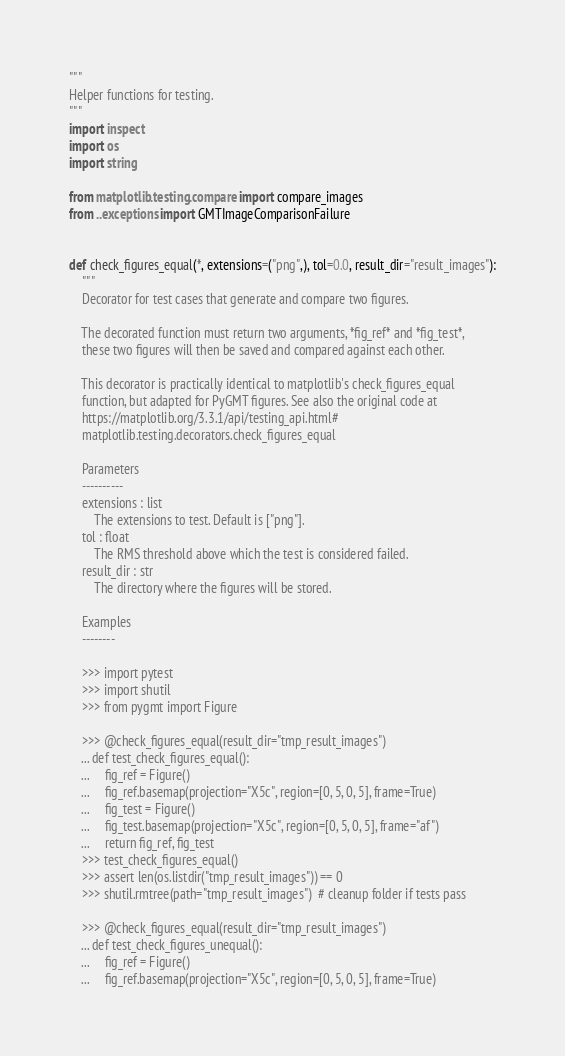<code> <loc_0><loc_0><loc_500><loc_500><_Python_>"""
Helper functions for testing.
"""
import inspect
import os
import string

from matplotlib.testing.compare import compare_images
from ..exceptions import GMTImageComparisonFailure


def check_figures_equal(*, extensions=("png",), tol=0.0, result_dir="result_images"):
    """
    Decorator for test cases that generate and compare two figures.

    The decorated function must return two arguments, *fig_ref* and *fig_test*,
    these two figures will then be saved and compared against each other.

    This decorator is practically identical to matplotlib's check_figures_equal
    function, but adapted for PyGMT figures. See also the original code at
    https://matplotlib.org/3.3.1/api/testing_api.html#
    matplotlib.testing.decorators.check_figures_equal

    Parameters
    ----------
    extensions : list
        The extensions to test. Default is ["png"].
    tol : float
        The RMS threshold above which the test is considered failed.
    result_dir : str
        The directory where the figures will be stored.

    Examples
    --------

    >>> import pytest
    >>> import shutil
    >>> from pygmt import Figure

    >>> @check_figures_equal(result_dir="tmp_result_images")
    ... def test_check_figures_equal():
    ...     fig_ref = Figure()
    ...     fig_ref.basemap(projection="X5c", region=[0, 5, 0, 5], frame=True)
    ...     fig_test = Figure()
    ...     fig_test.basemap(projection="X5c", region=[0, 5, 0, 5], frame="af")
    ...     return fig_ref, fig_test
    >>> test_check_figures_equal()
    >>> assert len(os.listdir("tmp_result_images")) == 0
    >>> shutil.rmtree(path="tmp_result_images")  # cleanup folder if tests pass

    >>> @check_figures_equal(result_dir="tmp_result_images")
    ... def test_check_figures_unequal():
    ...     fig_ref = Figure()
    ...     fig_ref.basemap(projection="X5c", region=[0, 5, 0, 5], frame=True)</code> 